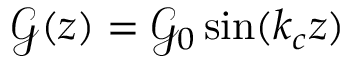Convert formula to latex. <formula><loc_0><loc_0><loc_500><loc_500>\mathcal { G } ( z ) = \mathcal { G } _ { 0 } \sin ( k _ { c } z )</formula> 